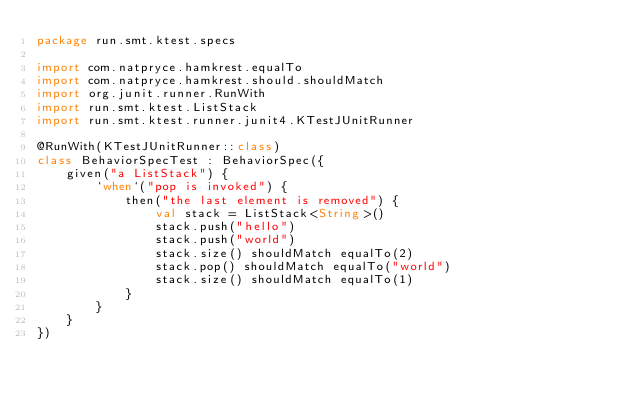Convert code to text. <code><loc_0><loc_0><loc_500><loc_500><_Kotlin_>package run.smt.ktest.specs

import com.natpryce.hamkrest.equalTo
import com.natpryce.hamkrest.should.shouldMatch
import org.junit.runner.RunWith
import run.smt.ktest.ListStack
import run.smt.ktest.runner.junit4.KTestJUnitRunner

@RunWith(KTestJUnitRunner::class)
class BehaviorSpecTest : BehaviorSpec({
    given("a ListStack") {
        `when`("pop is invoked") {
            then("the last element is removed") {
                val stack = ListStack<String>()
                stack.push("hello")
                stack.push("world")
                stack.size() shouldMatch equalTo(2)
                stack.pop() shouldMatch equalTo("world")
                stack.size() shouldMatch equalTo(1)
            }
        }
    }
})
</code> 